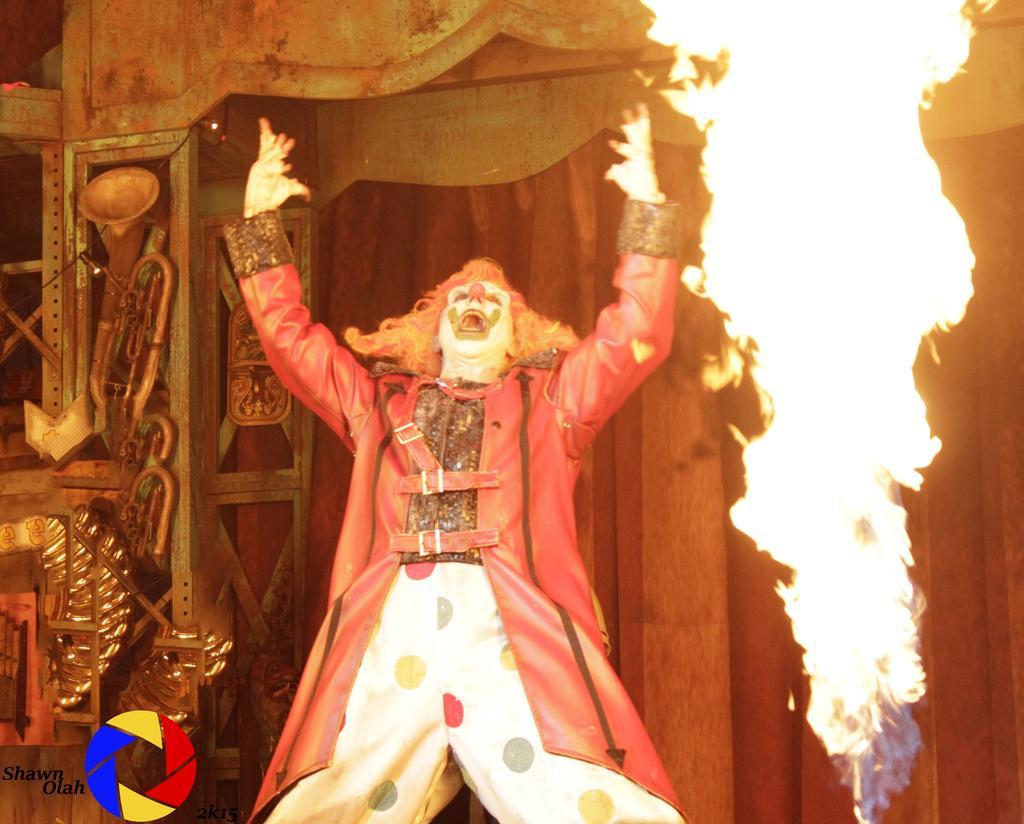Please provide a concise description of this image. In the middle of the image we can see a man, he wore costumes, beside him we can see fire, in the bottom left hand corner we can see some text and a logo. 